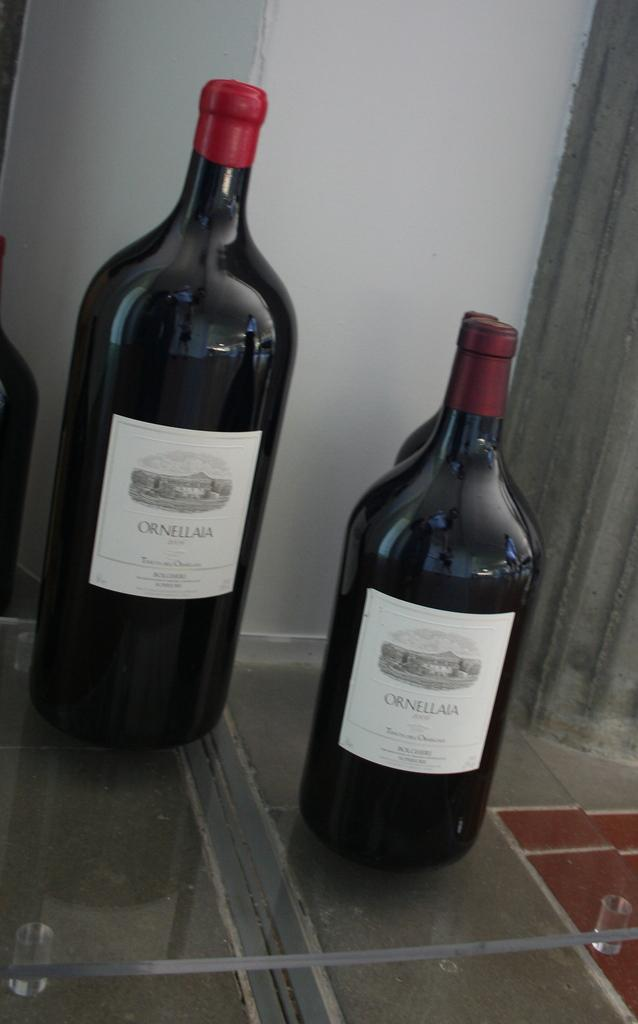<image>
Give a short and clear explanation of the subsequent image. Multiple closed bottles of Ornellaia wine with red seals. 